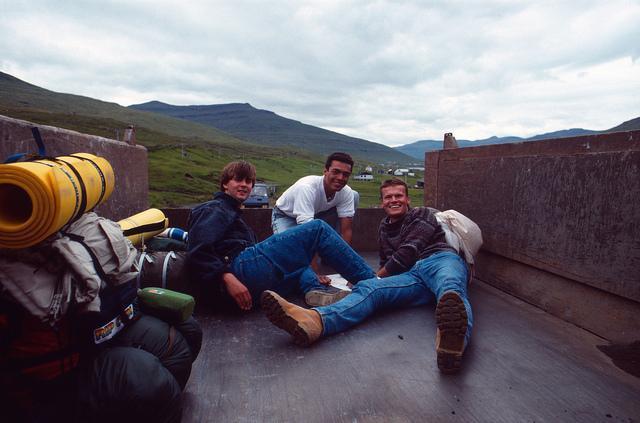How many men are there?
Give a very brief answer. 3. How many people are in the picture?
Give a very brief answer. 3. 